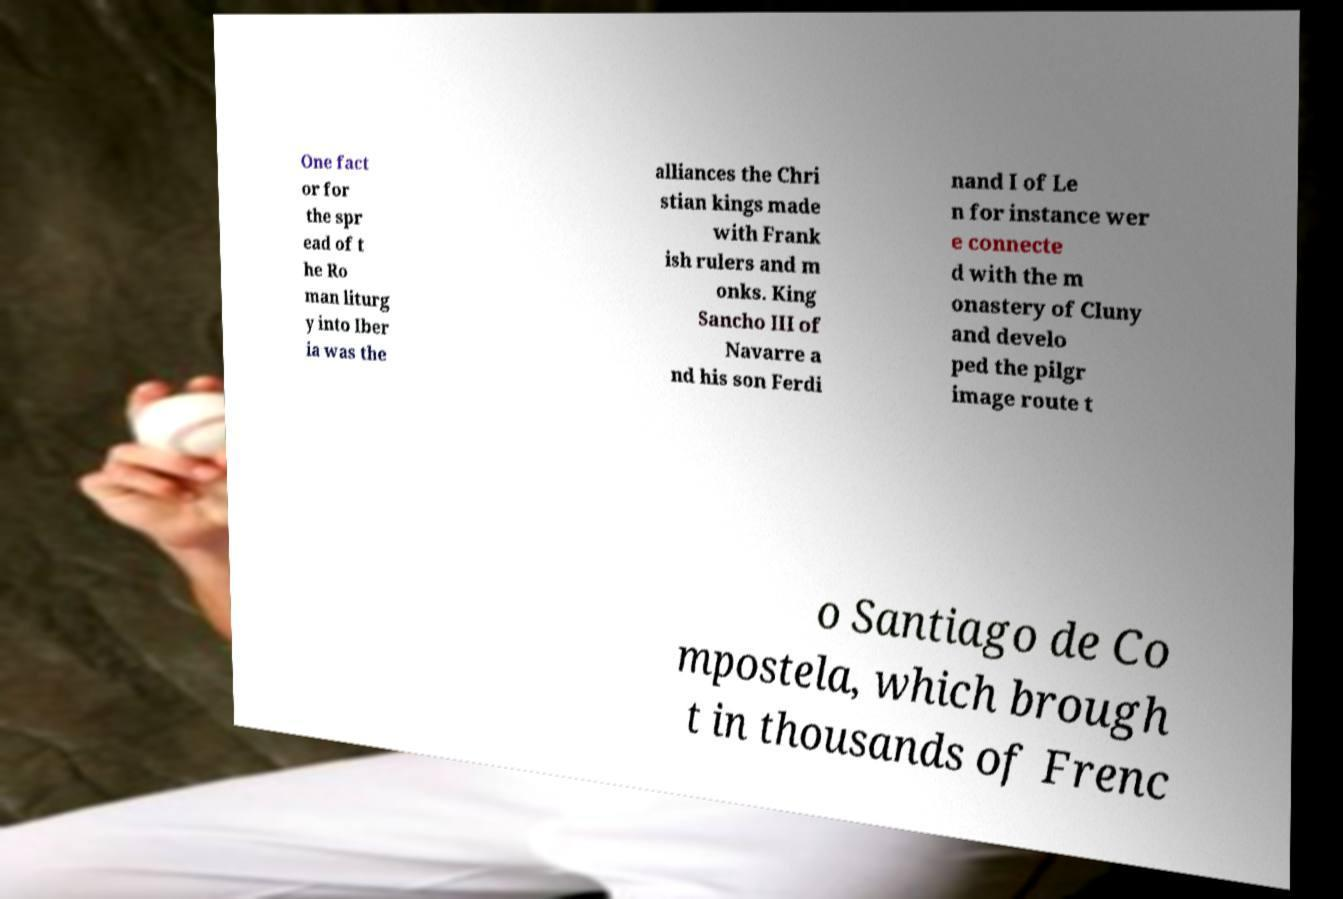There's text embedded in this image that I need extracted. Can you transcribe it verbatim? One fact or for the spr ead of t he Ro man liturg y into Iber ia was the alliances the Chri stian kings made with Frank ish rulers and m onks. King Sancho III of Navarre a nd his son Ferdi nand I of Le n for instance wer e connecte d with the m onastery of Cluny and develo ped the pilgr image route t o Santiago de Co mpostela, which brough t in thousands of Frenc 